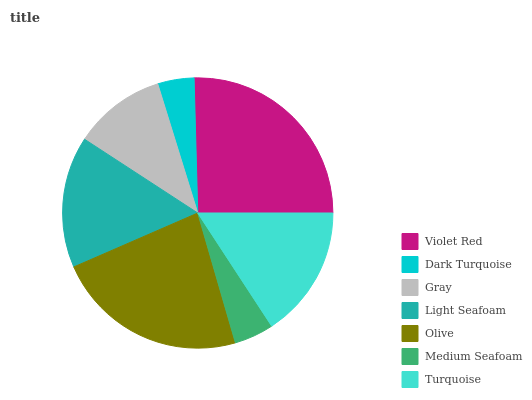Is Dark Turquoise the minimum?
Answer yes or no. Yes. Is Violet Red the maximum?
Answer yes or no. Yes. Is Gray the minimum?
Answer yes or no. No. Is Gray the maximum?
Answer yes or no. No. Is Gray greater than Dark Turquoise?
Answer yes or no. Yes. Is Dark Turquoise less than Gray?
Answer yes or no. Yes. Is Dark Turquoise greater than Gray?
Answer yes or no. No. Is Gray less than Dark Turquoise?
Answer yes or no. No. Is Light Seafoam the high median?
Answer yes or no. Yes. Is Light Seafoam the low median?
Answer yes or no. Yes. Is Turquoise the high median?
Answer yes or no. No. Is Medium Seafoam the low median?
Answer yes or no. No. 